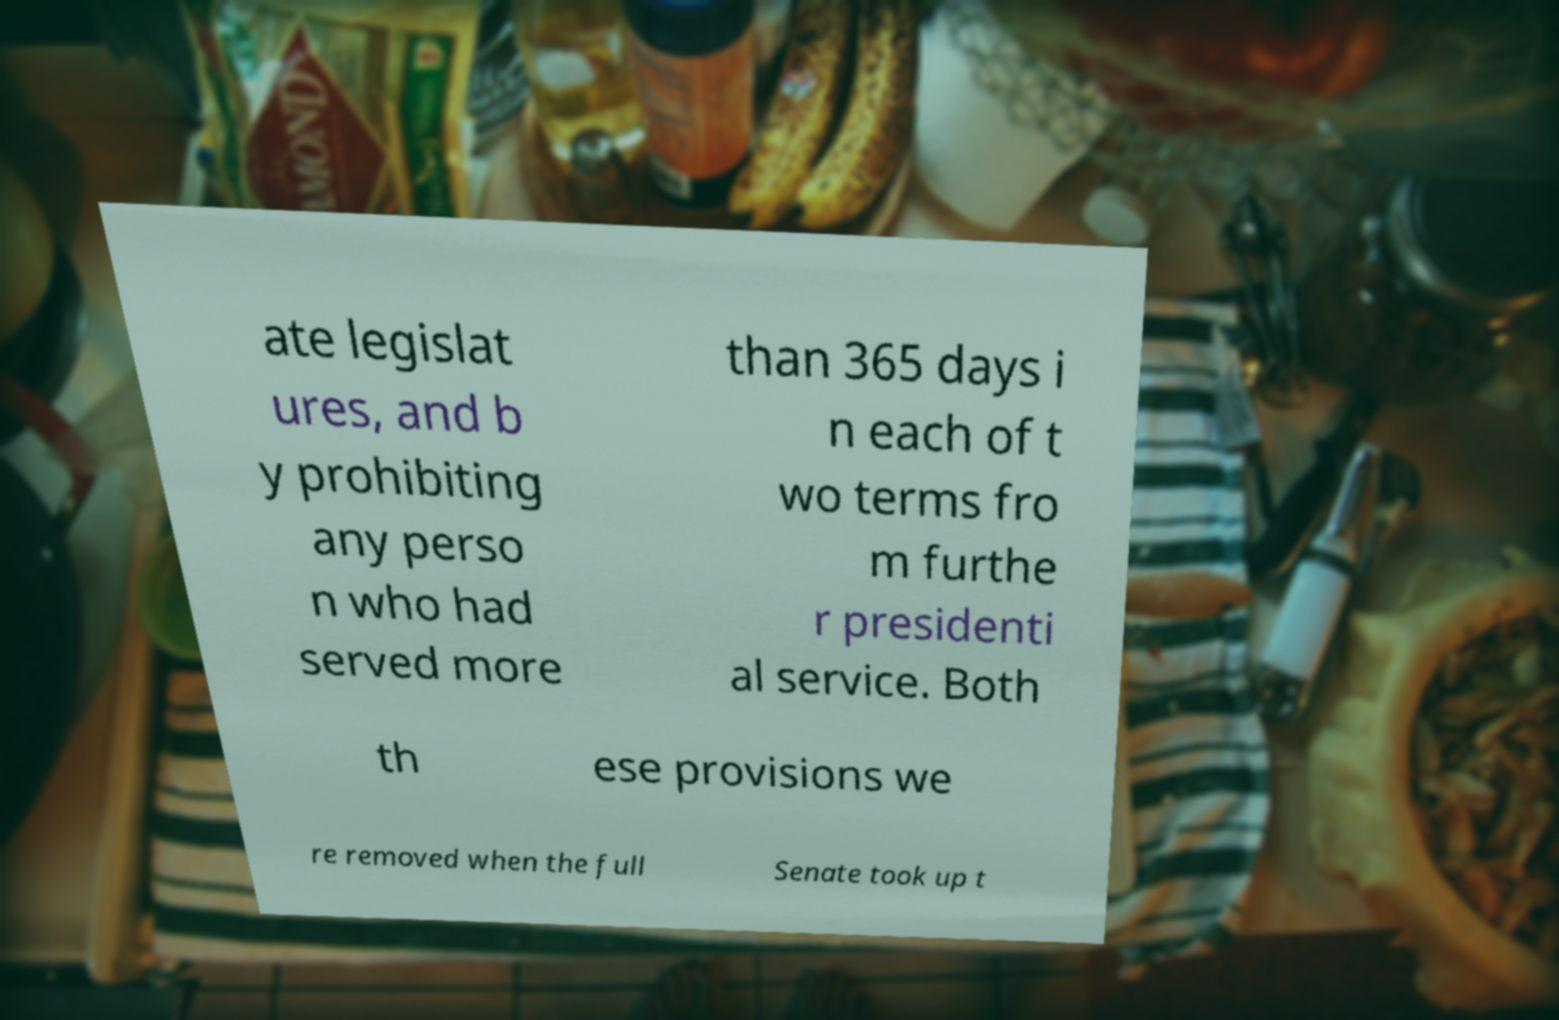Please identify and transcribe the text found in this image. ate legislat ures, and b y prohibiting any perso n who had served more than 365 days i n each of t wo terms fro m furthe r presidenti al service. Both th ese provisions we re removed when the full Senate took up t 